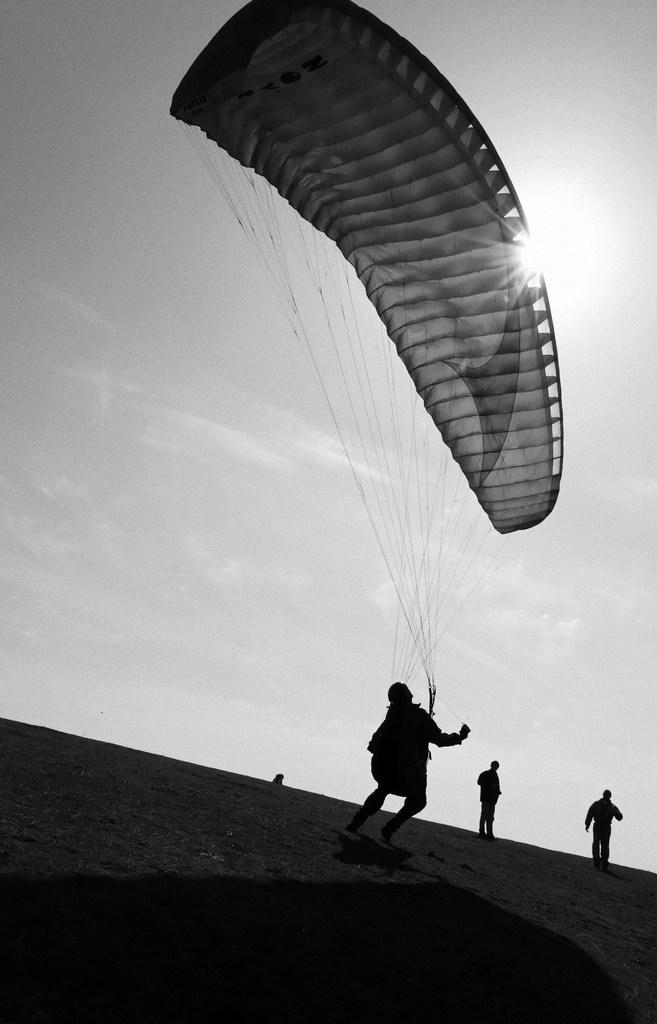What is the main subject in the middle of the image? There is a person with a parachute in the middle of the image. Who else can be seen in the image? There are two persons standing on the right side of the image. What is visible at the top of the image? The sky is visible at the top of the image. What is the color scheme of the image? The image is in black and white color. What type of brick is being used to build the parachute in the image? There is no brick present in the image, and the parachute is not being built. 